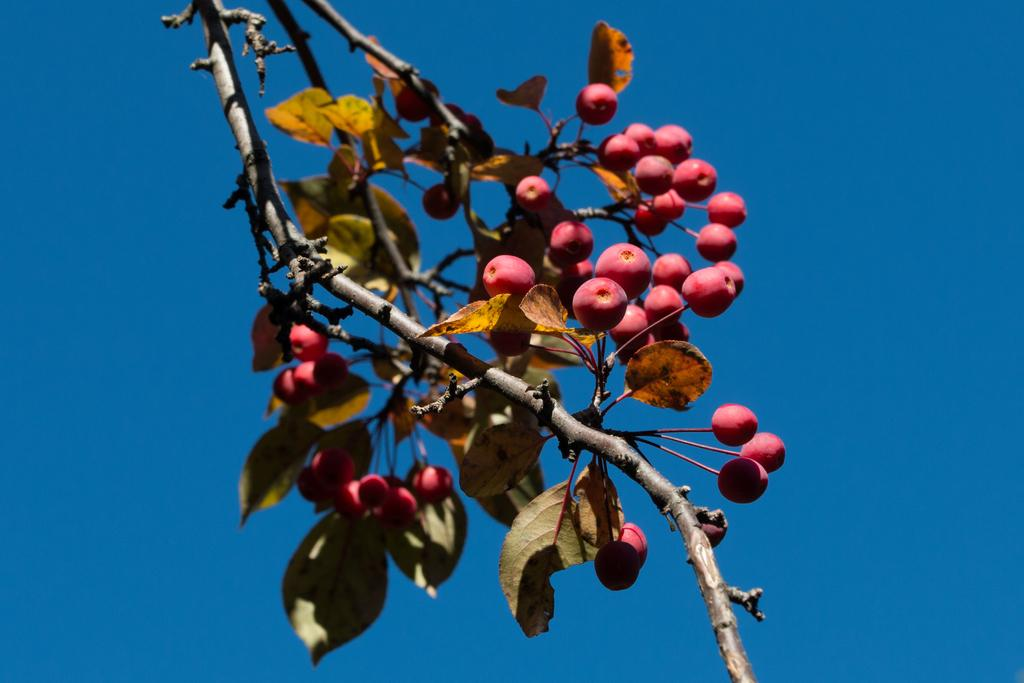What type of vegetation can be seen in the image? There are fruits on a tree in the image. What part of the natural environment is visible in the image? The sky is visible in the image. What type of event is taking place in the image? There is no event visible in the image; it simply shows a tree with fruits and the sky. Can you see a zipper on any of the fruits in the image? There are no zippers present on the fruits or any other objects in the image. 